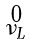<formula> <loc_0><loc_0><loc_500><loc_500>\begin{smallmatrix} 0 \\ \nu _ { L } \end{smallmatrix}</formula> 